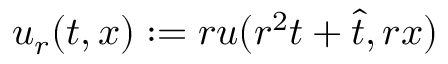Convert formula to latex. <formula><loc_0><loc_0><loc_500><loc_500>u _ { r } ( t , x ) \colon = r u ( r ^ { 2 } t + \hat { t } , r x )</formula> 